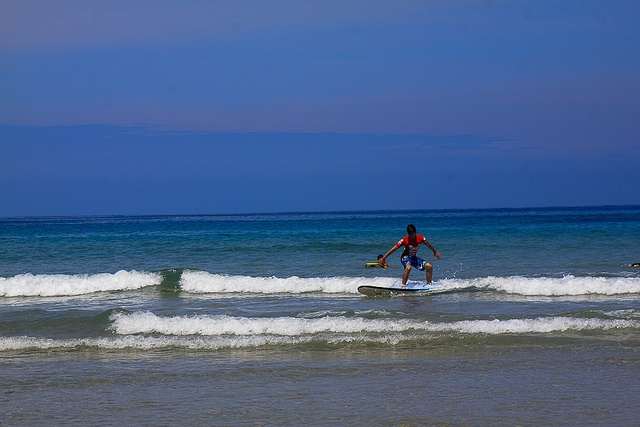Describe the objects in this image and their specific colors. I can see people in gray, black, maroon, navy, and blue tones, surfboard in gray, black, darkgreen, and darkgray tones, and surfboard in gray, black, darkgreen, and gold tones in this image. 